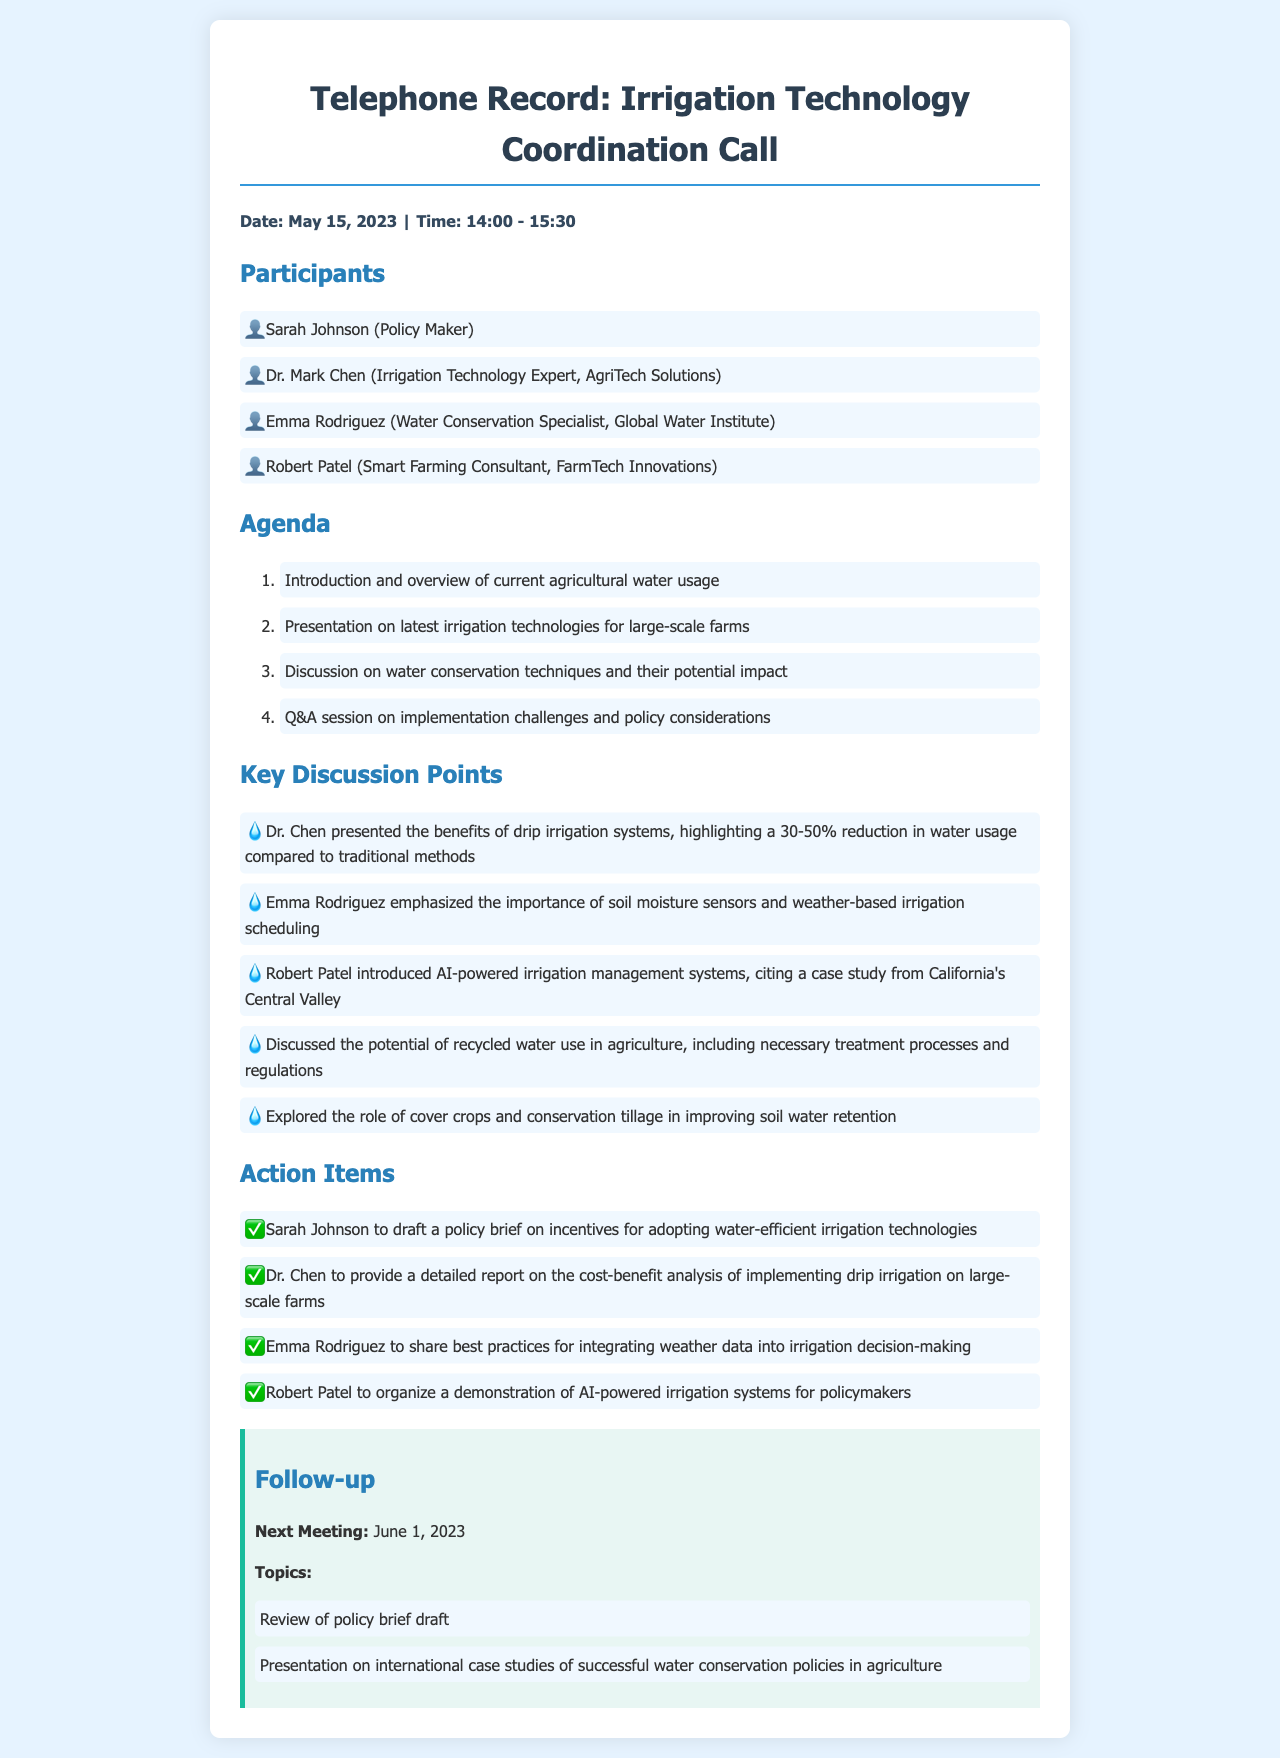What date was the coordination call held? The date of the call is explicitly mentioned in the document as "May 15, 2023."
Answer: May 15, 2023 Who is the water conservation specialist? The document lists participants, identifying Emma Rodriguez as the water conservation specialist.
Answer: Emma Rodriguez What is one benefit of drip irrigation systems mentioned? Dr. Chen presented that drip irrigation systems offer a 30-50% reduction in water usage compared to traditional methods.
Answer: 30-50% What is the main topic discussed regarding AI-powered irrigation systems? Robert Patel introduced AI-powered irrigation management systems, referencing a case study from California’s Central Valley.
Answer: California's Central Valley What does Sarah Johnson need to draft? The action items specify that Sarah Johnson is tasked with drafting a policy brief on incentives for adopting water-efficient irrigation technologies.
Answer: Policy brief How often will the group meet? The follow-up section indicates that the next meeting is scheduled for June 1, 2023, suggesting regular meetings.
Answer: Regular meetings What strategy was emphasized for improving soil water retention? The key discussion points mention the role of cover crops and conservation tillage in enhancing soil water retention.
Answer: Cover crops and conservation tillage What will Emma Rodriguez share as part of her action item? The action items state that Emma Rodriguez will share best practices for integrating weather data into irrigation decision-making.
Answer: Best practices for integrating weather data What does the agenda include after the presentation on irrigation technologies? The agenda shows that the subsequent item is a discussion on water conservation techniques and their potential impact.
Answer: Discussion on water conservation techniques 